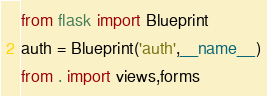<code> <loc_0><loc_0><loc_500><loc_500><_Python_>from flask import Blueprint
auth = Blueprint('auth',__name__)
from . import views,forms



</code> 